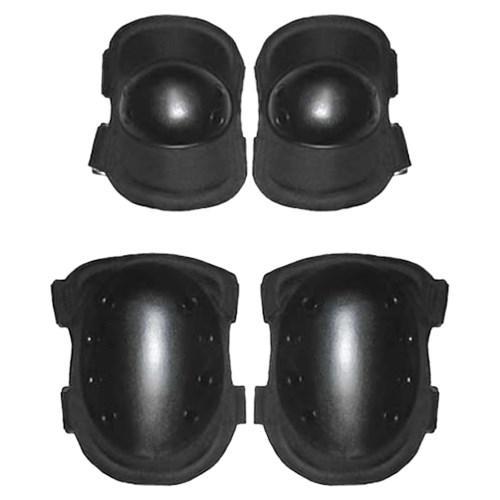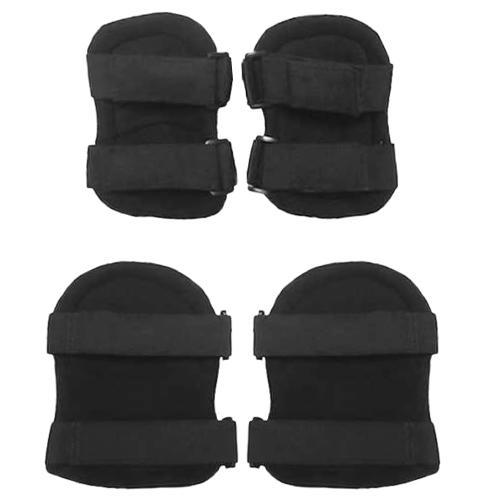The first image is the image on the left, the second image is the image on the right. Evaluate the accuracy of this statement regarding the images: "There are more pads in the image on the left than in the image on the right.". Is it true? Answer yes or no. No. The first image is the image on the left, the second image is the image on the right. For the images shown, is this caption "The combined images contain eight protective pads." true? Answer yes or no. Yes. 